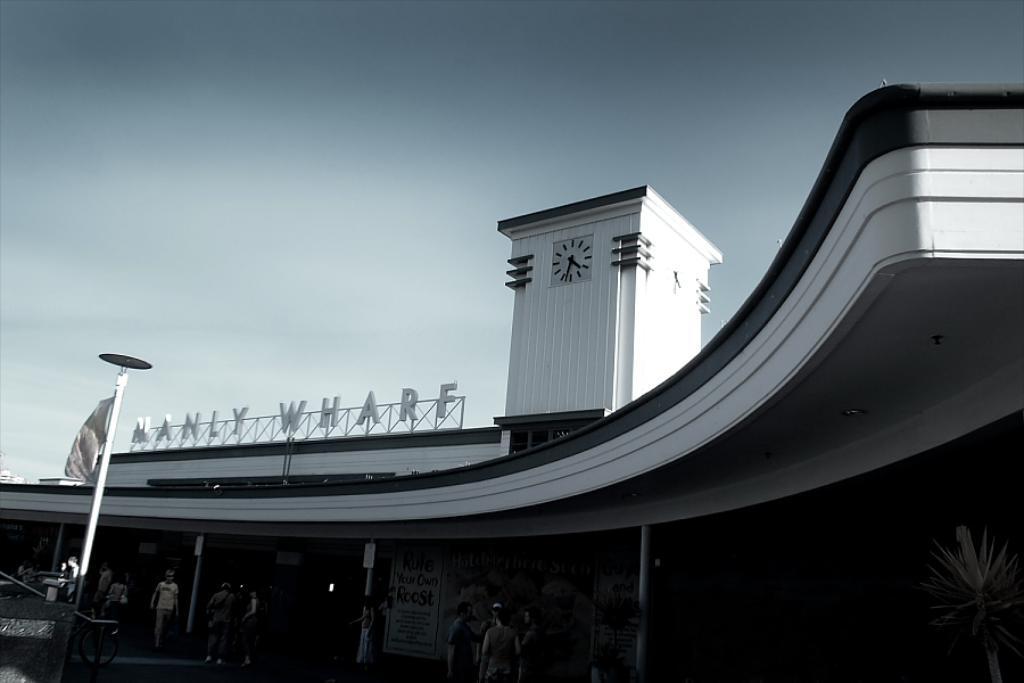Please provide a concise description of this image. This image consists of a building. It looks like an airport. In the front, we can see a clock on the wall. At the top, there are clouds in the sky. At the bottom, there are many people walking. 